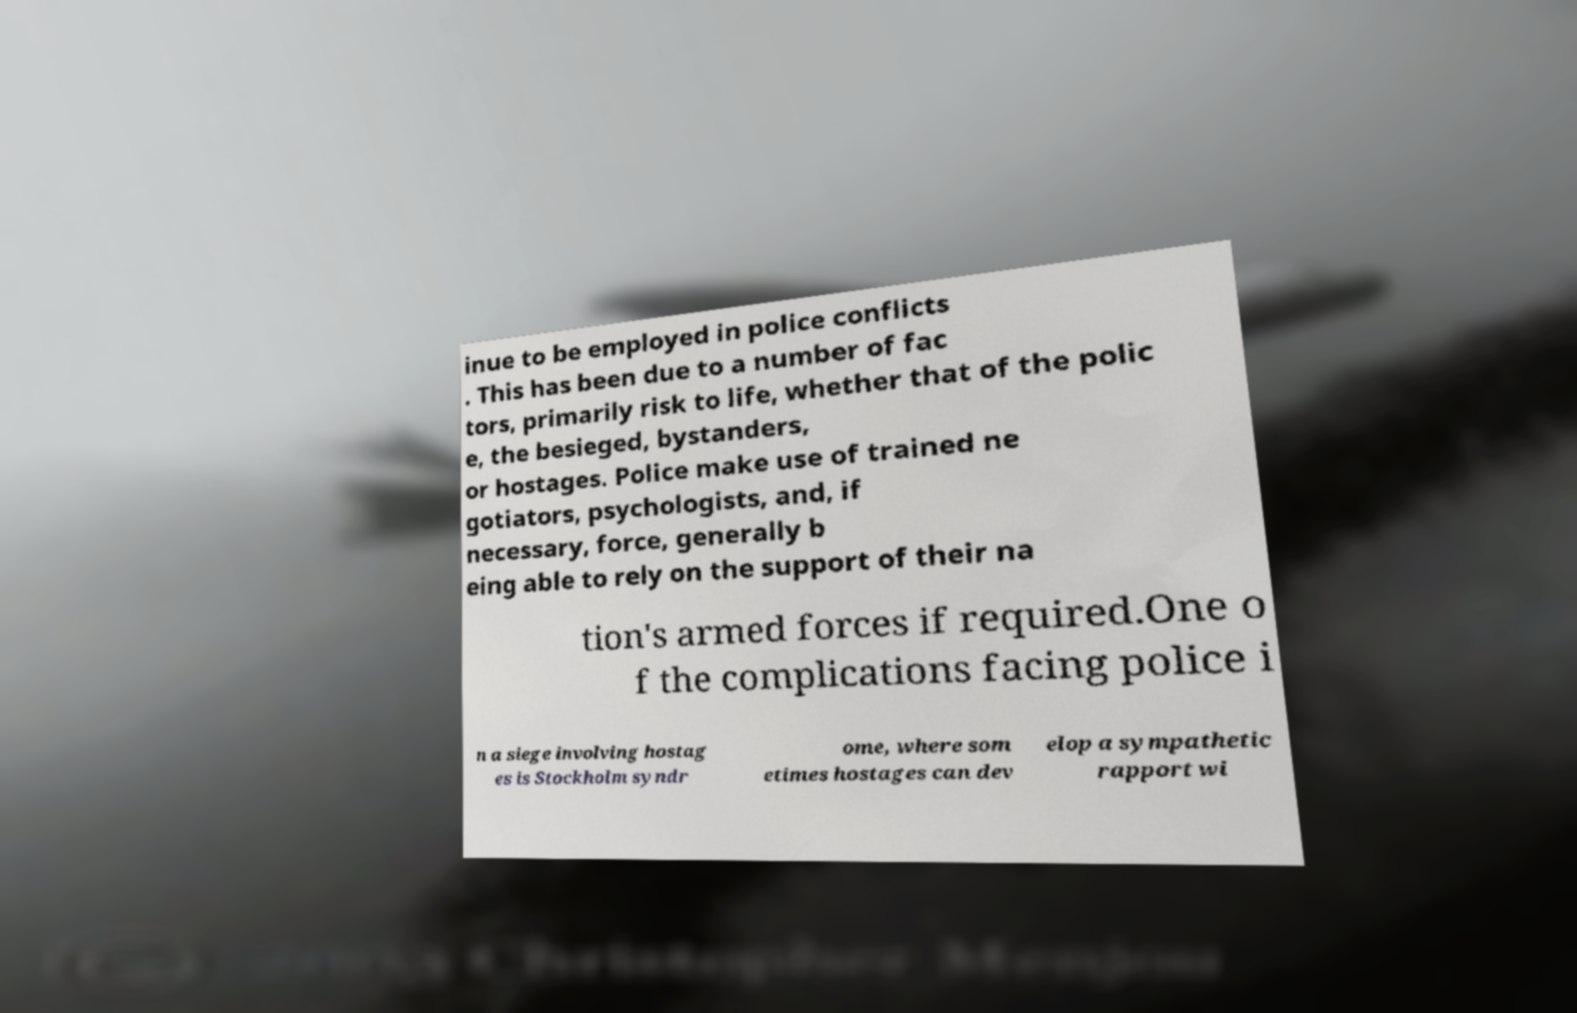What messages or text are displayed in this image? I need them in a readable, typed format. inue to be employed in police conflicts . This has been due to a number of fac tors, primarily risk to life, whether that of the polic e, the besieged, bystanders, or hostages. Police make use of trained ne gotiators, psychologists, and, if necessary, force, generally b eing able to rely on the support of their na tion's armed forces if required.One o f the complications facing police i n a siege involving hostag es is Stockholm syndr ome, where som etimes hostages can dev elop a sympathetic rapport wi 